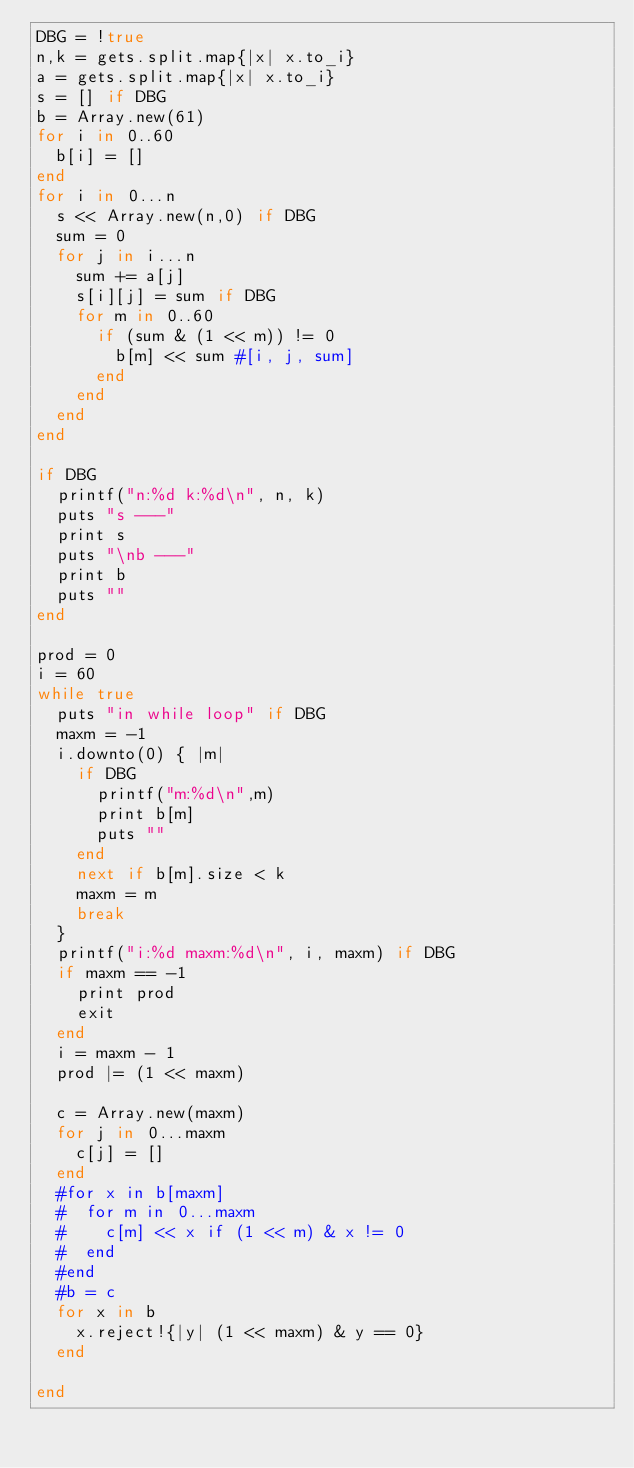<code> <loc_0><loc_0><loc_500><loc_500><_Ruby_>DBG = !true
n,k = gets.split.map{|x| x.to_i}
a = gets.split.map{|x| x.to_i}
s = [] if DBG
b = Array.new(61)
for i in 0..60
  b[i] = []
end
for i in 0...n
  s << Array.new(n,0) if DBG
  sum = 0
  for j in i...n
    sum += a[j]
    s[i][j] = sum if DBG
    for m in 0..60
      if (sum & (1 << m)) != 0
        b[m] << sum #[i, j, sum]
      end
    end
  end
end

if DBG
  printf("n:%d k:%d\n", n, k)
  puts "s ---"
  print s
  puts "\nb ---"
  print b
  puts ""
end

prod = 0
i = 60
while true
  puts "in while loop" if DBG
  maxm = -1
  i.downto(0) { |m|
    if DBG
      printf("m:%d\n",m)
      print b[m]
      puts ""
    end
    next if b[m].size < k
    maxm = m
    break
  }
  printf("i:%d maxm:%d\n", i, maxm) if DBG
  if maxm == -1
    print prod
    exit
  end
  i = maxm - 1
  prod |= (1 << maxm)

  c = Array.new(maxm)
  for j in 0...maxm
    c[j] = []
  end
  #for x in b[maxm]
  #  for m in 0...maxm
  #    c[m] << x if (1 << m) & x != 0
  #  end
  #end
  #b = c
  for x in b
    x.reject!{|y| (1 << maxm) & y == 0}
  end

end
</code> 